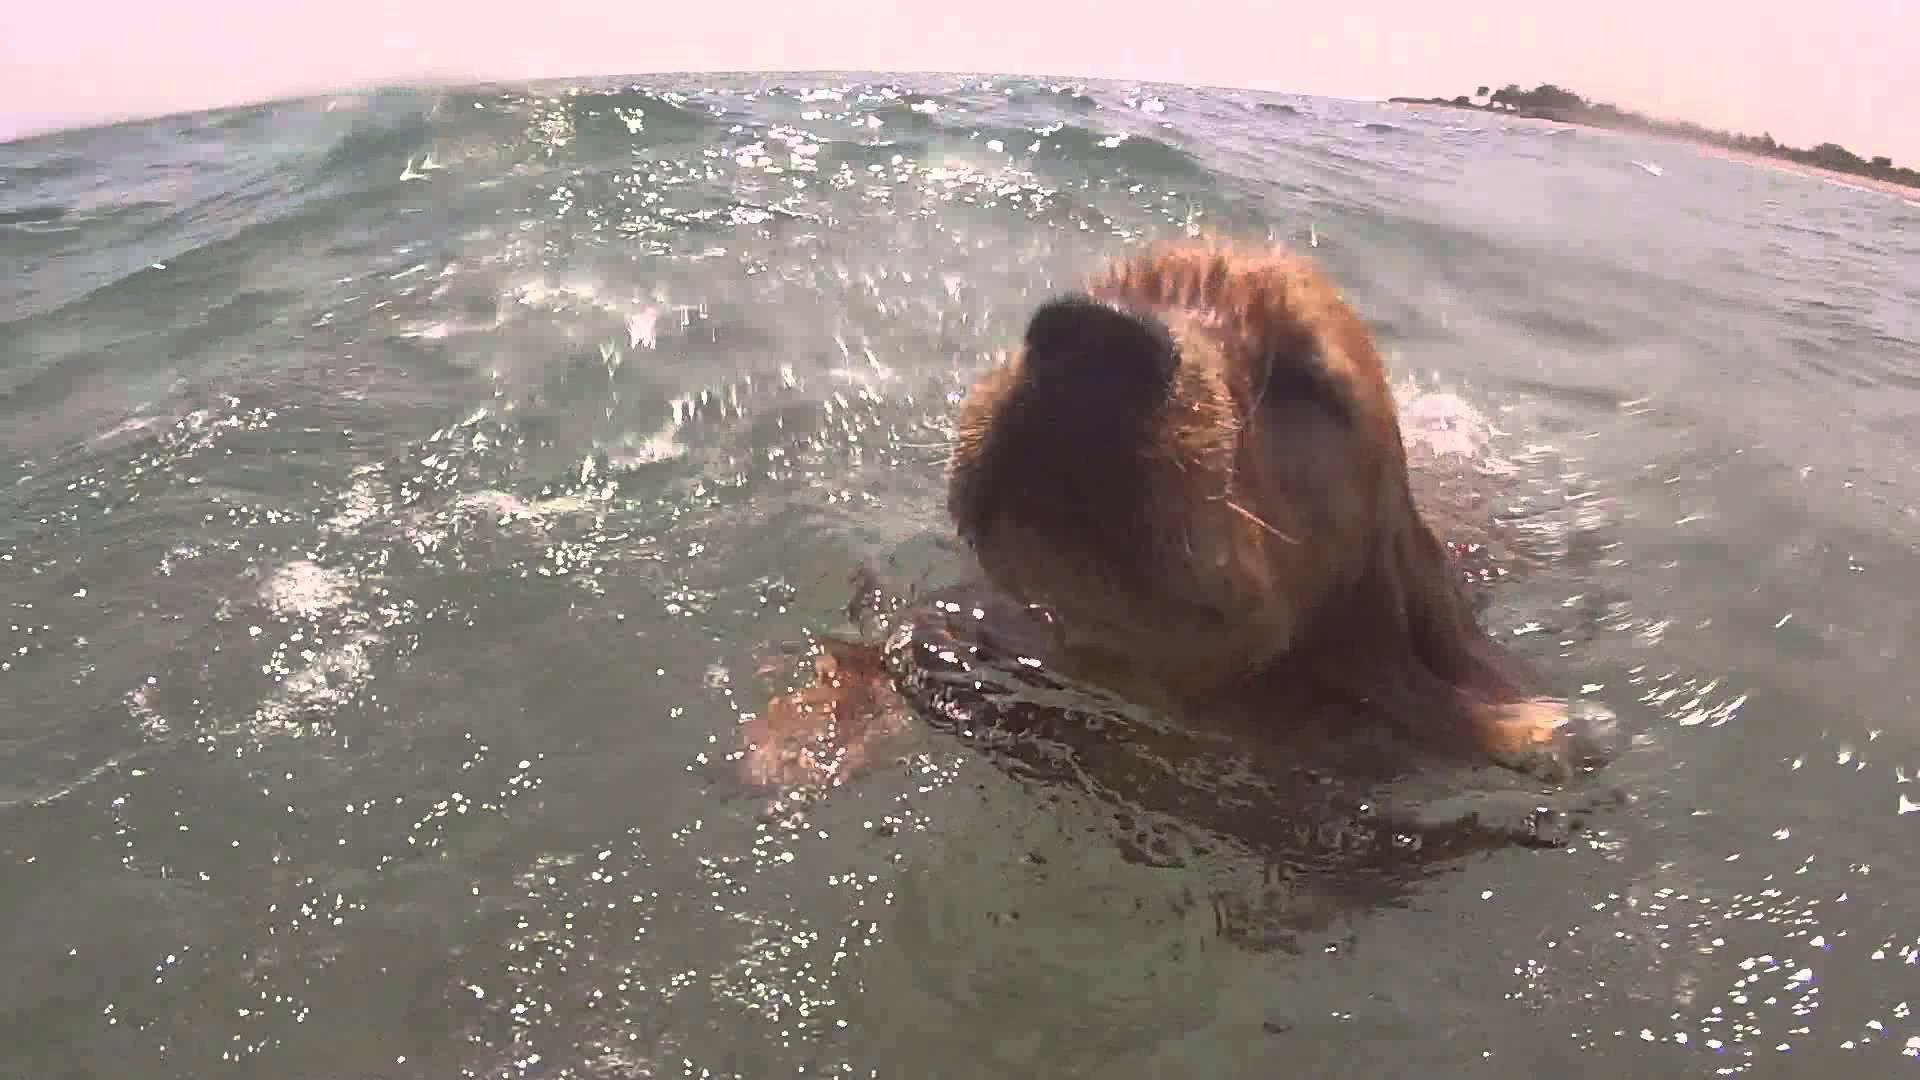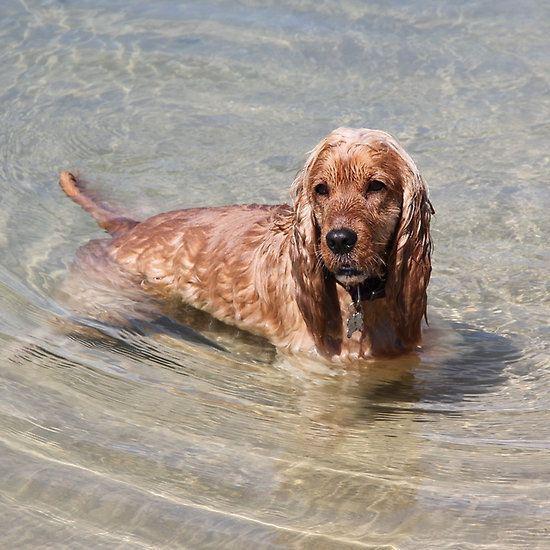The first image is the image on the left, the second image is the image on the right. Given the left and right images, does the statement "An image shows a dog swimming leftward with a stick-shaped object in its mouth." hold true? Answer yes or no. No. The first image is the image on the left, the second image is the image on the right. For the images shown, is this caption "The dog in the image on the right is standing in the water." true? Answer yes or no. Yes. 